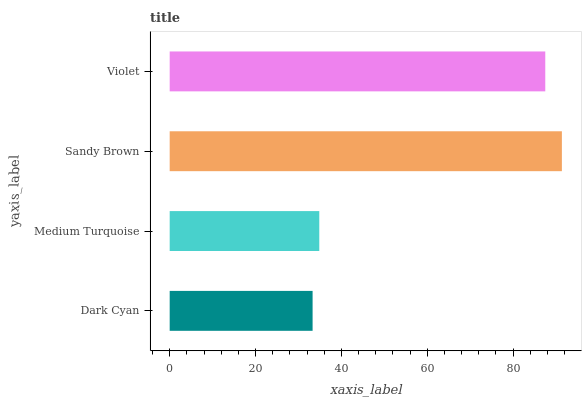Is Dark Cyan the minimum?
Answer yes or no. Yes. Is Sandy Brown the maximum?
Answer yes or no. Yes. Is Medium Turquoise the minimum?
Answer yes or no. No. Is Medium Turquoise the maximum?
Answer yes or no. No. Is Medium Turquoise greater than Dark Cyan?
Answer yes or no. Yes. Is Dark Cyan less than Medium Turquoise?
Answer yes or no. Yes. Is Dark Cyan greater than Medium Turquoise?
Answer yes or no. No. Is Medium Turquoise less than Dark Cyan?
Answer yes or no. No. Is Violet the high median?
Answer yes or no. Yes. Is Medium Turquoise the low median?
Answer yes or no. Yes. Is Dark Cyan the high median?
Answer yes or no. No. Is Sandy Brown the low median?
Answer yes or no. No. 